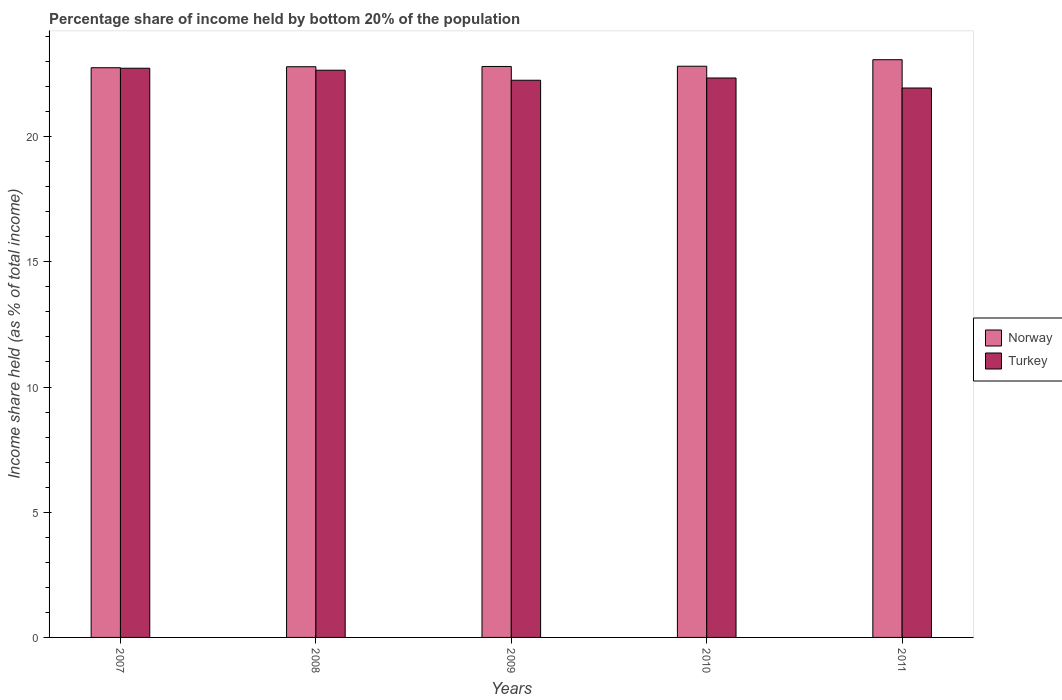How many different coloured bars are there?
Your response must be concise. 2. How many groups of bars are there?
Ensure brevity in your answer.  5. Are the number of bars per tick equal to the number of legend labels?
Your answer should be compact. Yes. Are the number of bars on each tick of the X-axis equal?
Offer a very short reply. Yes. How many bars are there on the 1st tick from the right?
Make the answer very short. 2. What is the label of the 1st group of bars from the left?
Give a very brief answer. 2007. In how many cases, is the number of bars for a given year not equal to the number of legend labels?
Give a very brief answer. 0. What is the share of income held by bottom 20% of the population in Norway in 2009?
Make the answer very short. 22.8. Across all years, what is the maximum share of income held by bottom 20% of the population in Norway?
Offer a terse response. 23.07. Across all years, what is the minimum share of income held by bottom 20% of the population in Turkey?
Make the answer very short. 21.94. What is the total share of income held by bottom 20% of the population in Turkey in the graph?
Your answer should be very brief. 111.91. What is the difference between the share of income held by bottom 20% of the population in Turkey in 2007 and that in 2010?
Provide a short and direct response. 0.39. What is the difference between the share of income held by bottom 20% of the population in Norway in 2008 and the share of income held by bottom 20% of the population in Turkey in 2010?
Your answer should be compact. 0.45. What is the average share of income held by bottom 20% of the population in Turkey per year?
Provide a succinct answer. 22.38. In the year 2008, what is the difference between the share of income held by bottom 20% of the population in Turkey and share of income held by bottom 20% of the population in Norway?
Your answer should be very brief. -0.14. What is the ratio of the share of income held by bottom 20% of the population in Norway in 2007 to that in 2008?
Offer a very short reply. 1. Is the share of income held by bottom 20% of the population in Turkey in 2007 less than that in 2011?
Your response must be concise. No. Is the difference between the share of income held by bottom 20% of the population in Turkey in 2009 and 2011 greater than the difference between the share of income held by bottom 20% of the population in Norway in 2009 and 2011?
Give a very brief answer. Yes. What is the difference between the highest and the second highest share of income held by bottom 20% of the population in Norway?
Provide a short and direct response. 0.26. What is the difference between the highest and the lowest share of income held by bottom 20% of the population in Turkey?
Your answer should be very brief. 0.79. In how many years, is the share of income held by bottom 20% of the population in Turkey greater than the average share of income held by bottom 20% of the population in Turkey taken over all years?
Your response must be concise. 2. What does the 1st bar from the left in 2010 represents?
Keep it short and to the point. Norway. Are all the bars in the graph horizontal?
Give a very brief answer. No. How many years are there in the graph?
Make the answer very short. 5. What is the difference between two consecutive major ticks on the Y-axis?
Keep it short and to the point. 5. Does the graph contain any zero values?
Your answer should be compact. No. Where does the legend appear in the graph?
Give a very brief answer. Center right. How are the legend labels stacked?
Give a very brief answer. Vertical. What is the title of the graph?
Make the answer very short. Percentage share of income held by bottom 20% of the population. What is the label or title of the Y-axis?
Your answer should be compact. Income share held (as % of total income). What is the Income share held (as % of total income) in Norway in 2007?
Your response must be concise. 22.75. What is the Income share held (as % of total income) in Turkey in 2007?
Provide a succinct answer. 22.73. What is the Income share held (as % of total income) in Norway in 2008?
Provide a succinct answer. 22.79. What is the Income share held (as % of total income) in Turkey in 2008?
Offer a terse response. 22.65. What is the Income share held (as % of total income) in Norway in 2009?
Provide a succinct answer. 22.8. What is the Income share held (as % of total income) of Turkey in 2009?
Keep it short and to the point. 22.25. What is the Income share held (as % of total income) in Norway in 2010?
Provide a short and direct response. 22.81. What is the Income share held (as % of total income) of Turkey in 2010?
Offer a terse response. 22.34. What is the Income share held (as % of total income) in Norway in 2011?
Your response must be concise. 23.07. What is the Income share held (as % of total income) in Turkey in 2011?
Offer a very short reply. 21.94. Across all years, what is the maximum Income share held (as % of total income) of Norway?
Keep it short and to the point. 23.07. Across all years, what is the maximum Income share held (as % of total income) in Turkey?
Provide a short and direct response. 22.73. Across all years, what is the minimum Income share held (as % of total income) of Norway?
Your answer should be compact. 22.75. Across all years, what is the minimum Income share held (as % of total income) in Turkey?
Your answer should be very brief. 21.94. What is the total Income share held (as % of total income) of Norway in the graph?
Provide a short and direct response. 114.22. What is the total Income share held (as % of total income) in Turkey in the graph?
Offer a terse response. 111.91. What is the difference between the Income share held (as % of total income) in Norway in 2007 and that in 2008?
Provide a succinct answer. -0.04. What is the difference between the Income share held (as % of total income) in Turkey in 2007 and that in 2009?
Your answer should be very brief. 0.48. What is the difference between the Income share held (as % of total income) in Norway in 2007 and that in 2010?
Make the answer very short. -0.06. What is the difference between the Income share held (as % of total income) in Turkey in 2007 and that in 2010?
Your answer should be very brief. 0.39. What is the difference between the Income share held (as % of total income) of Norway in 2007 and that in 2011?
Provide a succinct answer. -0.32. What is the difference between the Income share held (as % of total income) in Turkey in 2007 and that in 2011?
Keep it short and to the point. 0.79. What is the difference between the Income share held (as % of total income) in Norway in 2008 and that in 2009?
Offer a terse response. -0.01. What is the difference between the Income share held (as % of total income) of Norway in 2008 and that in 2010?
Make the answer very short. -0.02. What is the difference between the Income share held (as % of total income) in Turkey in 2008 and that in 2010?
Provide a succinct answer. 0.31. What is the difference between the Income share held (as % of total income) of Norway in 2008 and that in 2011?
Ensure brevity in your answer.  -0.28. What is the difference between the Income share held (as % of total income) in Turkey in 2008 and that in 2011?
Offer a terse response. 0.71. What is the difference between the Income share held (as % of total income) in Norway in 2009 and that in 2010?
Offer a very short reply. -0.01. What is the difference between the Income share held (as % of total income) of Turkey in 2009 and that in 2010?
Give a very brief answer. -0.09. What is the difference between the Income share held (as % of total income) in Norway in 2009 and that in 2011?
Provide a short and direct response. -0.27. What is the difference between the Income share held (as % of total income) of Turkey in 2009 and that in 2011?
Provide a short and direct response. 0.31. What is the difference between the Income share held (as % of total income) of Norway in 2010 and that in 2011?
Ensure brevity in your answer.  -0.26. What is the difference between the Income share held (as % of total income) of Norway in 2007 and the Income share held (as % of total income) of Turkey in 2008?
Ensure brevity in your answer.  0.1. What is the difference between the Income share held (as % of total income) in Norway in 2007 and the Income share held (as % of total income) in Turkey in 2009?
Provide a short and direct response. 0.5. What is the difference between the Income share held (as % of total income) of Norway in 2007 and the Income share held (as % of total income) of Turkey in 2010?
Provide a succinct answer. 0.41. What is the difference between the Income share held (as % of total income) of Norway in 2007 and the Income share held (as % of total income) of Turkey in 2011?
Ensure brevity in your answer.  0.81. What is the difference between the Income share held (as % of total income) of Norway in 2008 and the Income share held (as % of total income) of Turkey in 2009?
Your answer should be very brief. 0.54. What is the difference between the Income share held (as % of total income) in Norway in 2008 and the Income share held (as % of total income) in Turkey in 2010?
Keep it short and to the point. 0.45. What is the difference between the Income share held (as % of total income) of Norway in 2009 and the Income share held (as % of total income) of Turkey in 2010?
Provide a short and direct response. 0.46. What is the difference between the Income share held (as % of total income) in Norway in 2009 and the Income share held (as % of total income) in Turkey in 2011?
Provide a succinct answer. 0.86. What is the difference between the Income share held (as % of total income) in Norway in 2010 and the Income share held (as % of total income) in Turkey in 2011?
Offer a terse response. 0.87. What is the average Income share held (as % of total income) of Norway per year?
Make the answer very short. 22.84. What is the average Income share held (as % of total income) of Turkey per year?
Your response must be concise. 22.38. In the year 2007, what is the difference between the Income share held (as % of total income) of Norway and Income share held (as % of total income) of Turkey?
Your answer should be compact. 0.02. In the year 2008, what is the difference between the Income share held (as % of total income) in Norway and Income share held (as % of total income) in Turkey?
Provide a succinct answer. 0.14. In the year 2009, what is the difference between the Income share held (as % of total income) of Norway and Income share held (as % of total income) of Turkey?
Keep it short and to the point. 0.55. In the year 2010, what is the difference between the Income share held (as % of total income) of Norway and Income share held (as % of total income) of Turkey?
Provide a short and direct response. 0.47. In the year 2011, what is the difference between the Income share held (as % of total income) in Norway and Income share held (as % of total income) in Turkey?
Your answer should be compact. 1.13. What is the ratio of the Income share held (as % of total income) in Norway in 2007 to that in 2009?
Give a very brief answer. 1. What is the ratio of the Income share held (as % of total income) of Turkey in 2007 to that in 2009?
Provide a short and direct response. 1.02. What is the ratio of the Income share held (as % of total income) of Turkey in 2007 to that in 2010?
Offer a terse response. 1.02. What is the ratio of the Income share held (as % of total income) in Norway in 2007 to that in 2011?
Offer a very short reply. 0.99. What is the ratio of the Income share held (as % of total income) of Turkey in 2007 to that in 2011?
Keep it short and to the point. 1.04. What is the ratio of the Income share held (as % of total income) of Norway in 2008 to that in 2009?
Make the answer very short. 1. What is the ratio of the Income share held (as % of total income) in Turkey in 2008 to that in 2010?
Ensure brevity in your answer.  1.01. What is the ratio of the Income share held (as % of total income) in Norway in 2008 to that in 2011?
Ensure brevity in your answer.  0.99. What is the ratio of the Income share held (as % of total income) in Turkey in 2008 to that in 2011?
Offer a terse response. 1.03. What is the ratio of the Income share held (as % of total income) of Norway in 2009 to that in 2011?
Keep it short and to the point. 0.99. What is the ratio of the Income share held (as % of total income) of Turkey in 2009 to that in 2011?
Make the answer very short. 1.01. What is the ratio of the Income share held (as % of total income) of Norway in 2010 to that in 2011?
Ensure brevity in your answer.  0.99. What is the ratio of the Income share held (as % of total income) in Turkey in 2010 to that in 2011?
Provide a short and direct response. 1.02. What is the difference between the highest and the second highest Income share held (as % of total income) in Norway?
Provide a short and direct response. 0.26. What is the difference between the highest and the lowest Income share held (as % of total income) in Norway?
Make the answer very short. 0.32. What is the difference between the highest and the lowest Income share held (as % of total income) in Turkey?
Your response must be concise. 0.79. 